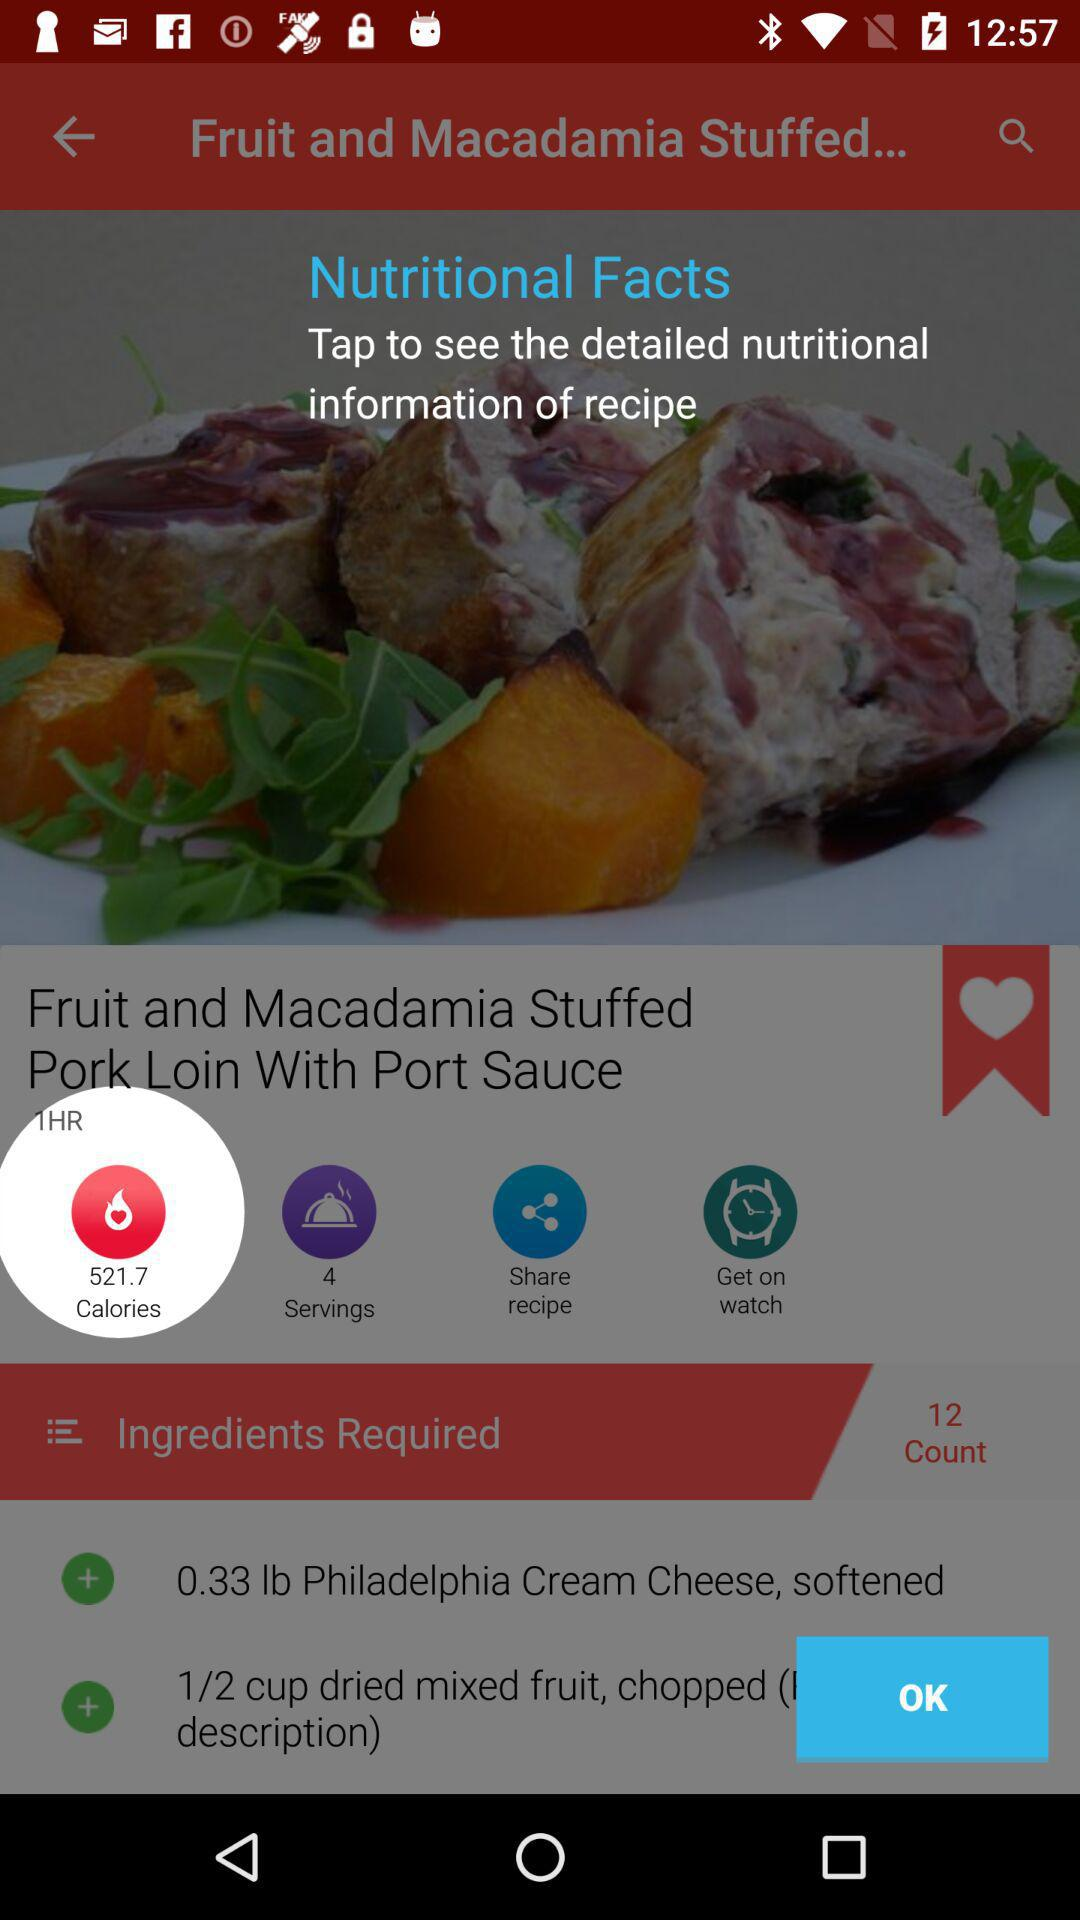How many calories are in this recipe?
Answer the question using a single word or phrase. 521.7 